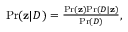Convert formula to latex. <formula><loc_0><loc_0><loc_500><loc_500>\begin{array} { r } { P r ( { \mathbf z } | D ) = \frac { P r ( { \mathbf z } ) P r ( D | { \mathbf z } ) } { P r ( D ) } , } \end{array}</formula> 